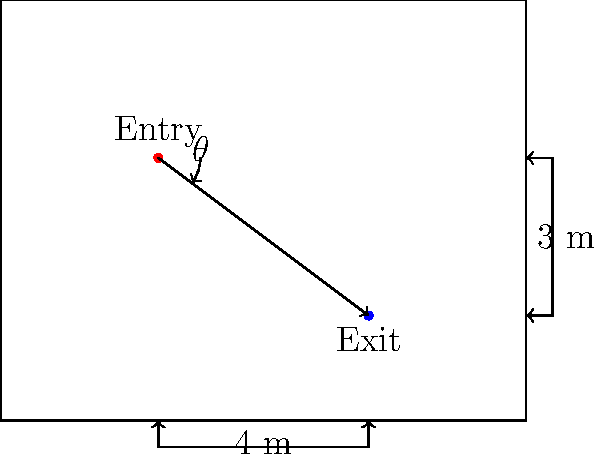In a crime scene recreation, a bullet trajectory needs to be determined. The entry point is 5 meters high on one wall, and the exit point is 2 meters high on the opposite wall, which is 4 meters away. What is the angle $\theta$ (in degrees) between the bullet trajectory and the horizontal plane? To solve this problem, we'll use trigonometry:

1. Visualize the scenario as a right triangle, where:
   - The horizontal distance between walls is the base (4 m)
   - The vertical distance between entry and exit points is the height (5 m - 2 m = 3 m)
   - The bullet trajectory is the hypotenuse

2. We need to find the angle between the hypotenuse (trajectory) and the base (horizontal plane).

3. This can be calculated using the arctangent function:
   $\theta = \arctan(\frac{\text{opposite}}{\text{adjacent}})$

4. Substitute the values:
   $\theta = \arctan(\frac{3}{4})$

5. Calculate:
   $\theta = \arctan(0.75) \approx 36.87°$

6. Round to two decimal places:
   $\theta \approx 36.87°$
Answer: $36.87°$ 